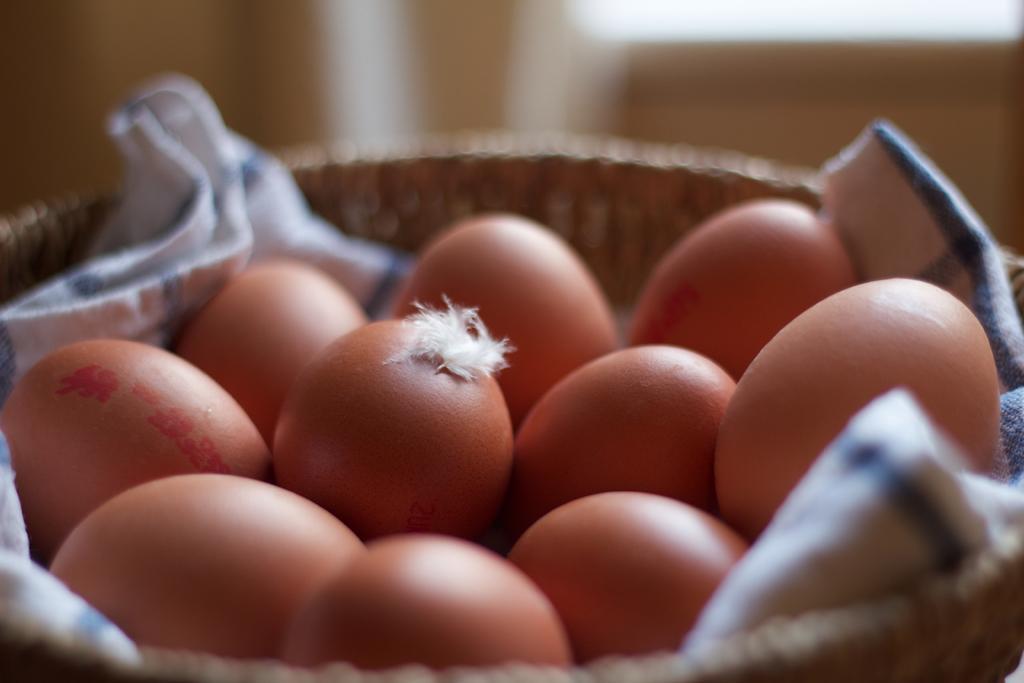Can you describe this image briefly? In this image in the center there is one basket, in the basket there is one cloth and eggs and the background is blurred. 